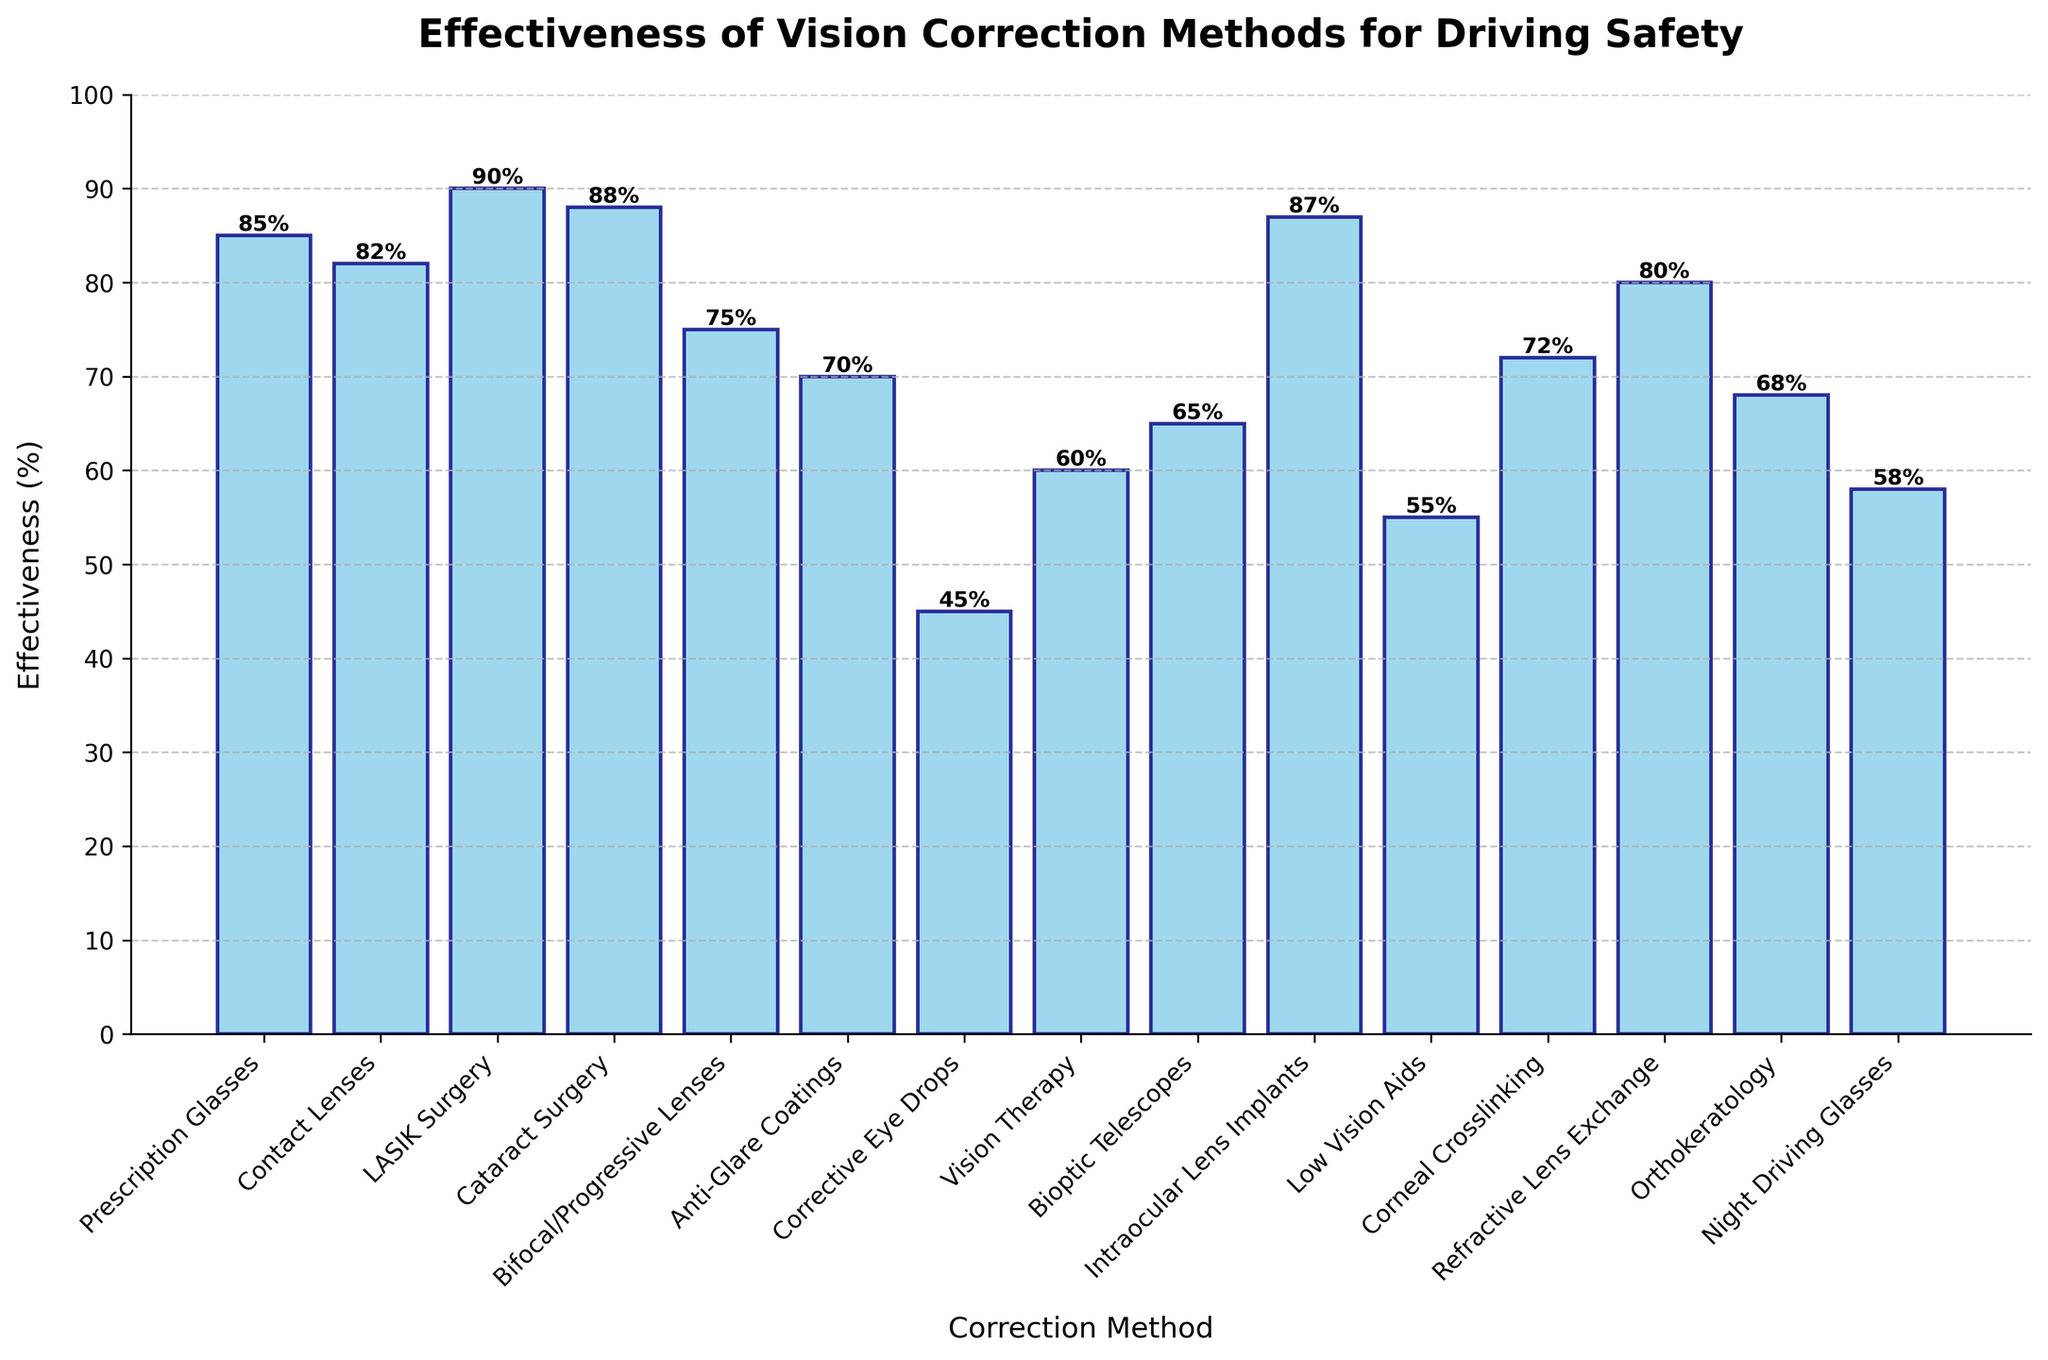Which method has the highest effectiveness percentage? The bars in the plot represent the effectiveness percentages of different methods. The bar labeled "LASIK Surgery" is the tallest one.
Answer: LASIK Surgery Which method has the lowest effectiveness percentage? The shortest bar in the plot corresponds to the method with the lowest effectiveness. The bar labeled "Corrective Eye Drops" is the shortest.
Answer: Corrective Eye Drops How much more effective is Cataract Surgery compared to Orthokeratology? Find the height of the bars labeled "Cataract Surgery" and "Orthokeratology". Cataract Surgery is at 88% and Orthokeratology is at 68%. The difference is 88 - 68 = 20.
Answer: 20% Which methods have an effectiveness of 75% or more? Identify the bars with heights equal to or greater than 75%. These bars correspond to methods "Prescription Glasses", "Contact Lenses", "LASIK Surgery", "Cataract Surgery", "Bifocal/Progressive Lenses", "Intraocular Lens Implants", "Refractive Lens Exchange".
Answer: Prescription Glasses, Contact Lenses, LASIK Surgery, Cataract Surgery, Bifocal/Progressive Lenses, Intraocular Lens Implants, Refractive Lens Exchange What is the average effectiveness of all methods combined? Sum the effectiveness percentages and divide by the number of methods. The total is (85 + 82 + 90 + 88 + 75 + 70 + 45 + 60 + 65 + 87 + 55 + 72 + 80 + 68 + 58) = 1000. The number of methods is 15. The average is 1000 / 15 = ~66.67%.
Answer: ~66.67% Is Anti-Glare Coatings more effective than Bioptic Telescopes? Compare the heights of the bars labeled "Anti-Glare Coatings" and "Bioptic Telescopes". Anti-Glare Coatings is at 70% and Bioptic Telescopes is at 65%.
Answer: Yes What is the median effectiveness percentage? Order the effectiveness percentages and find the middle value. The ordered values are [45, 55, 58, 60, 65, 68, 70, 72, 75, 80, 82, 85, 87, 88, 90]. The median value is the 8th value, which is 72%.
Answer: 72% What is the effectiveness difference between the most and least effective methods? Identify the most effective (LASIK Surgery at 90%) and the least effective (Corrective Eye Drops at 45%), then find the difference: 90 - 45 = 45.
Answer: 45% How many methods have an effectiveness below 60%? Count the bars with heights below 60%. These methods are "Corrective Eye Drops", "Low Vision Aids", "Night Driving Glasses", and "Vision Therapy".
Answer: 4 methods What is the combined effectiveness of Prescription Glasses and Intraocular Lens Implants? Sum the effectiveness percentages of the two methods: 85 (Prescription Glasses) + 87 (Intraocular Lens Implants) = 172.
Answer: 172% 